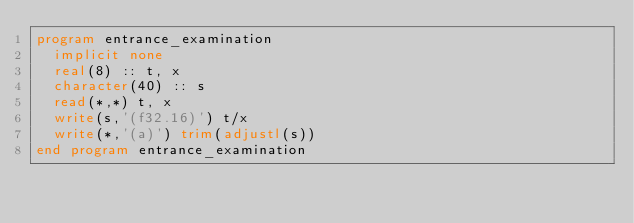<code> <loc_0><loc_0><loc_500><loc_500><_FORTRAN_>program entrance_examination
  implicit none
  real(8) :: t, x
  character(40) :: s
  read(*,*) t, x
  write(s,'(f32.16)') t/x
  write(*,'(a)') trim(adjustl(s))
end program entrance_examination</code> 